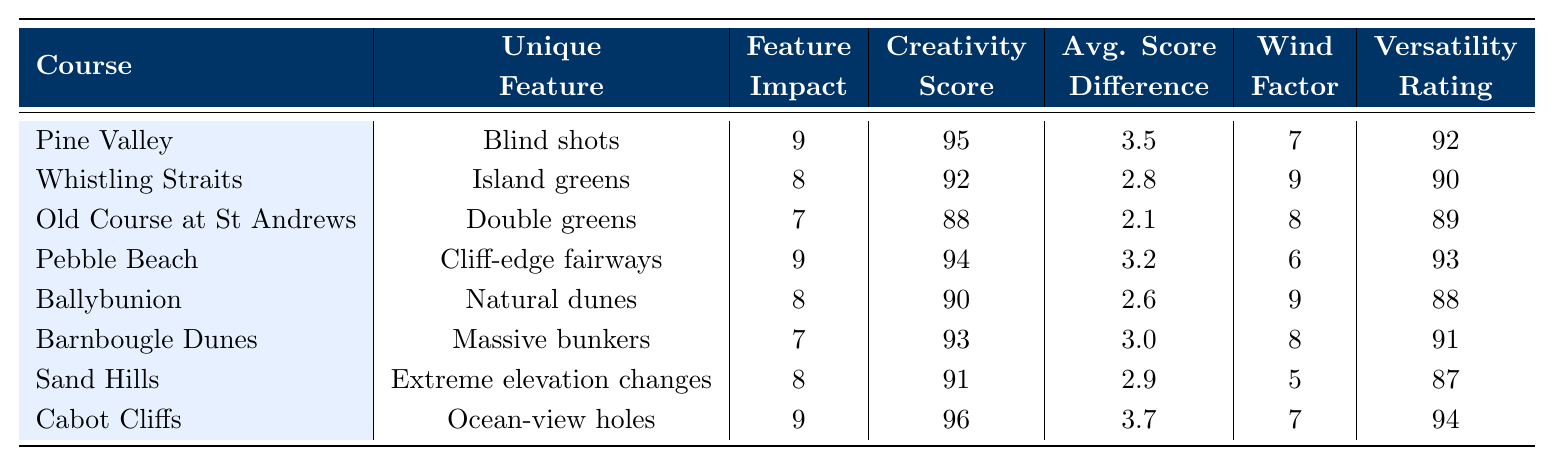What is the unique feature of Cabot Cliffs? According to the table, the unique feature listed for Cabot Cliffs is "Ocean-view holes."
Answer: Ocean-view holes Which course has the highest creativity score? The table shows that Cabot Cliffs has the highest creativity score of 96.
Answer: Cabot Cliffs What is the average feature impact for courses with a versatility rating above 90? The courses with a versatility rating above 90 are Pine Valley, Pebble Beach, Barnbougle Dunes, and Cabot Cliffs. Their feature impacts are 9, 9, 7, and 9, respectively. The average is (9 + 9 + 7 + 9) / 4 = 34 / 4 = 8.5.
Answer: 8.5 True or False: Old Course at St Andrews has a wind factor of 8. The table indicates that the wind factor for Old Course at St Andrews is indeed 8.
Answer: True Which course has the lowest average score difference? The average score differences for the courses are 3.5, 2.8, 2.1, 3.2, 2.6, 3.0, 2.9, and 3.7. The lowest value is 2.1 for Old Course at St Andrews.
Answer: Old Course at St Andrews Calculate the total impact score for all courses. To find the total impact score, sum the feature impacts: 9 + 8 + 7 + 9 + 8 + 7 + 8 + 9 = 66.
Answer: 66 Which course has the highest wind factor and what is that factor? The wind factors in the table are 7, 9, 8, 6, 9, 8, 5, and 7. The highest value is 9, and it is found in Whistling Straits and Ballybunion.
Answer: 9 (Whistling Straits and Ballybunion) What is the difference in creativity scores between the highest and lowest rated courses? The highest creativity score is 96 (Cabot Cliffs) and the lowest is 88 (Old Course at St Andrews). The difference is 96 - 88 = 8.
Answer: 8 Which courses have a feature impact of 8? According to the table, the courses with a feature impact of 8 are Whistling Straits, Ballybunion, and Sand Hills.
Answer: Whistling Straits, Ballybunion, Sand Hills Is the creativity score of Pebble Beach higher than that of Ballybunion? The creativity score for Pebble Beach is 94, and for Ballybunion, it is 90, making Pebble Beach's score higher.
Answer: Yes 